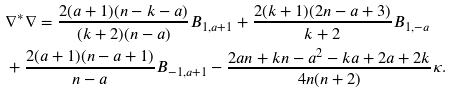<formula> <loc_0><loc_0><loc_500><loc_500>& \nabla ^ { \ast } \nabla = \frac { 2 ( a + 1 ) ( n - k - a ) } { ( k + 2 ) ( n - a ) } B _ { 1 , a + 1 } + \frac { 2 ( k + 1 ) ( 2 n - a + 3 ) } { k + 2 } B _ { 1 , - a } \\ & + \frac { 2 ( a + 1 ) ( n - a + 1 ) } { n - a } B _ { - 1 , a + 1 } - \frac { 2 a n + k n - a ^ { 2 } - k a + 2 a + 2 k } { 4 n ( n + 2 ) } \kappa .</formula> 